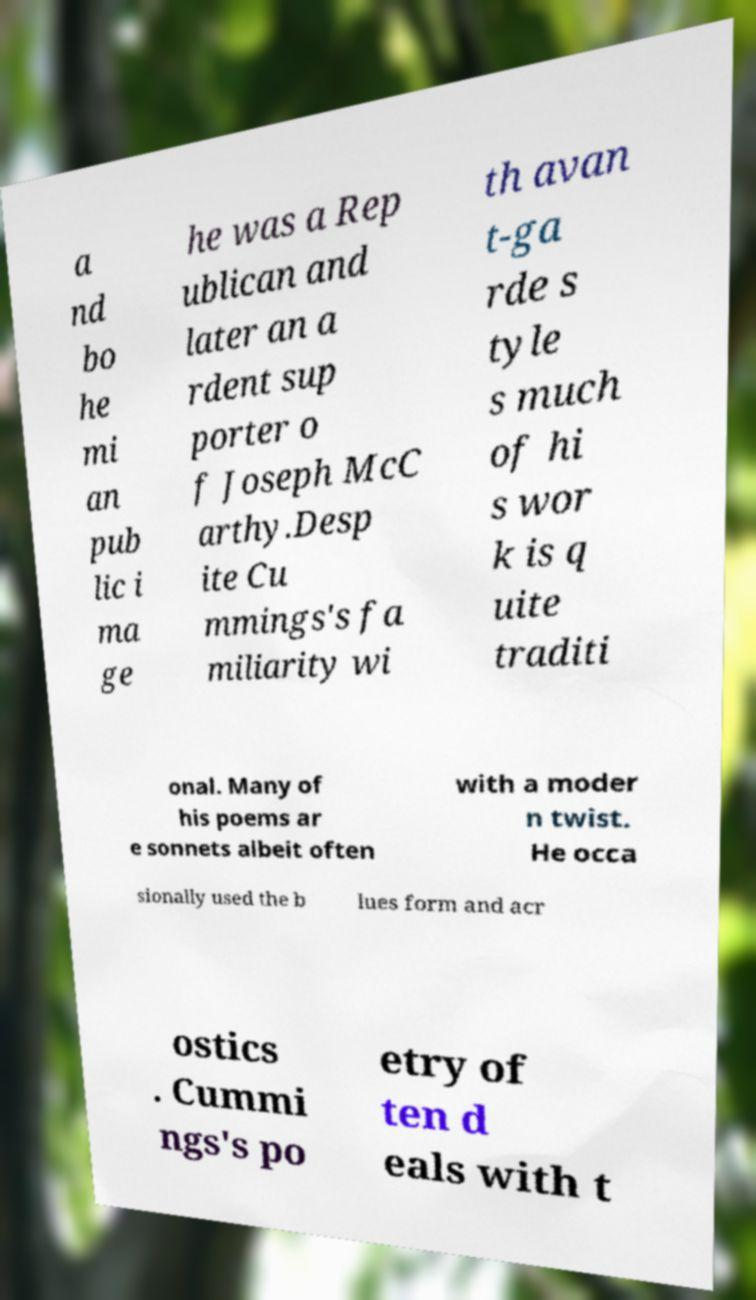Can you read and provide the text displayed in the image?This photo seems to have some interesting text. Can you extract and type it out for me? a nd bo he mi an pub lic i ma ge he was a Rep ublican and later an a rdent sup porter o f Joseph McC arthy.Desp ite Cu mmings's fa miliarity wi th avan t-ga rde s tyle s much of hi s wor k is q uite traditi onal. Many of his poems ar e sonnets albeit often with a moder n twist. He occa sionally used the b lues form and acr ostics . Cummi ngs's po etry of ten d eals with t 